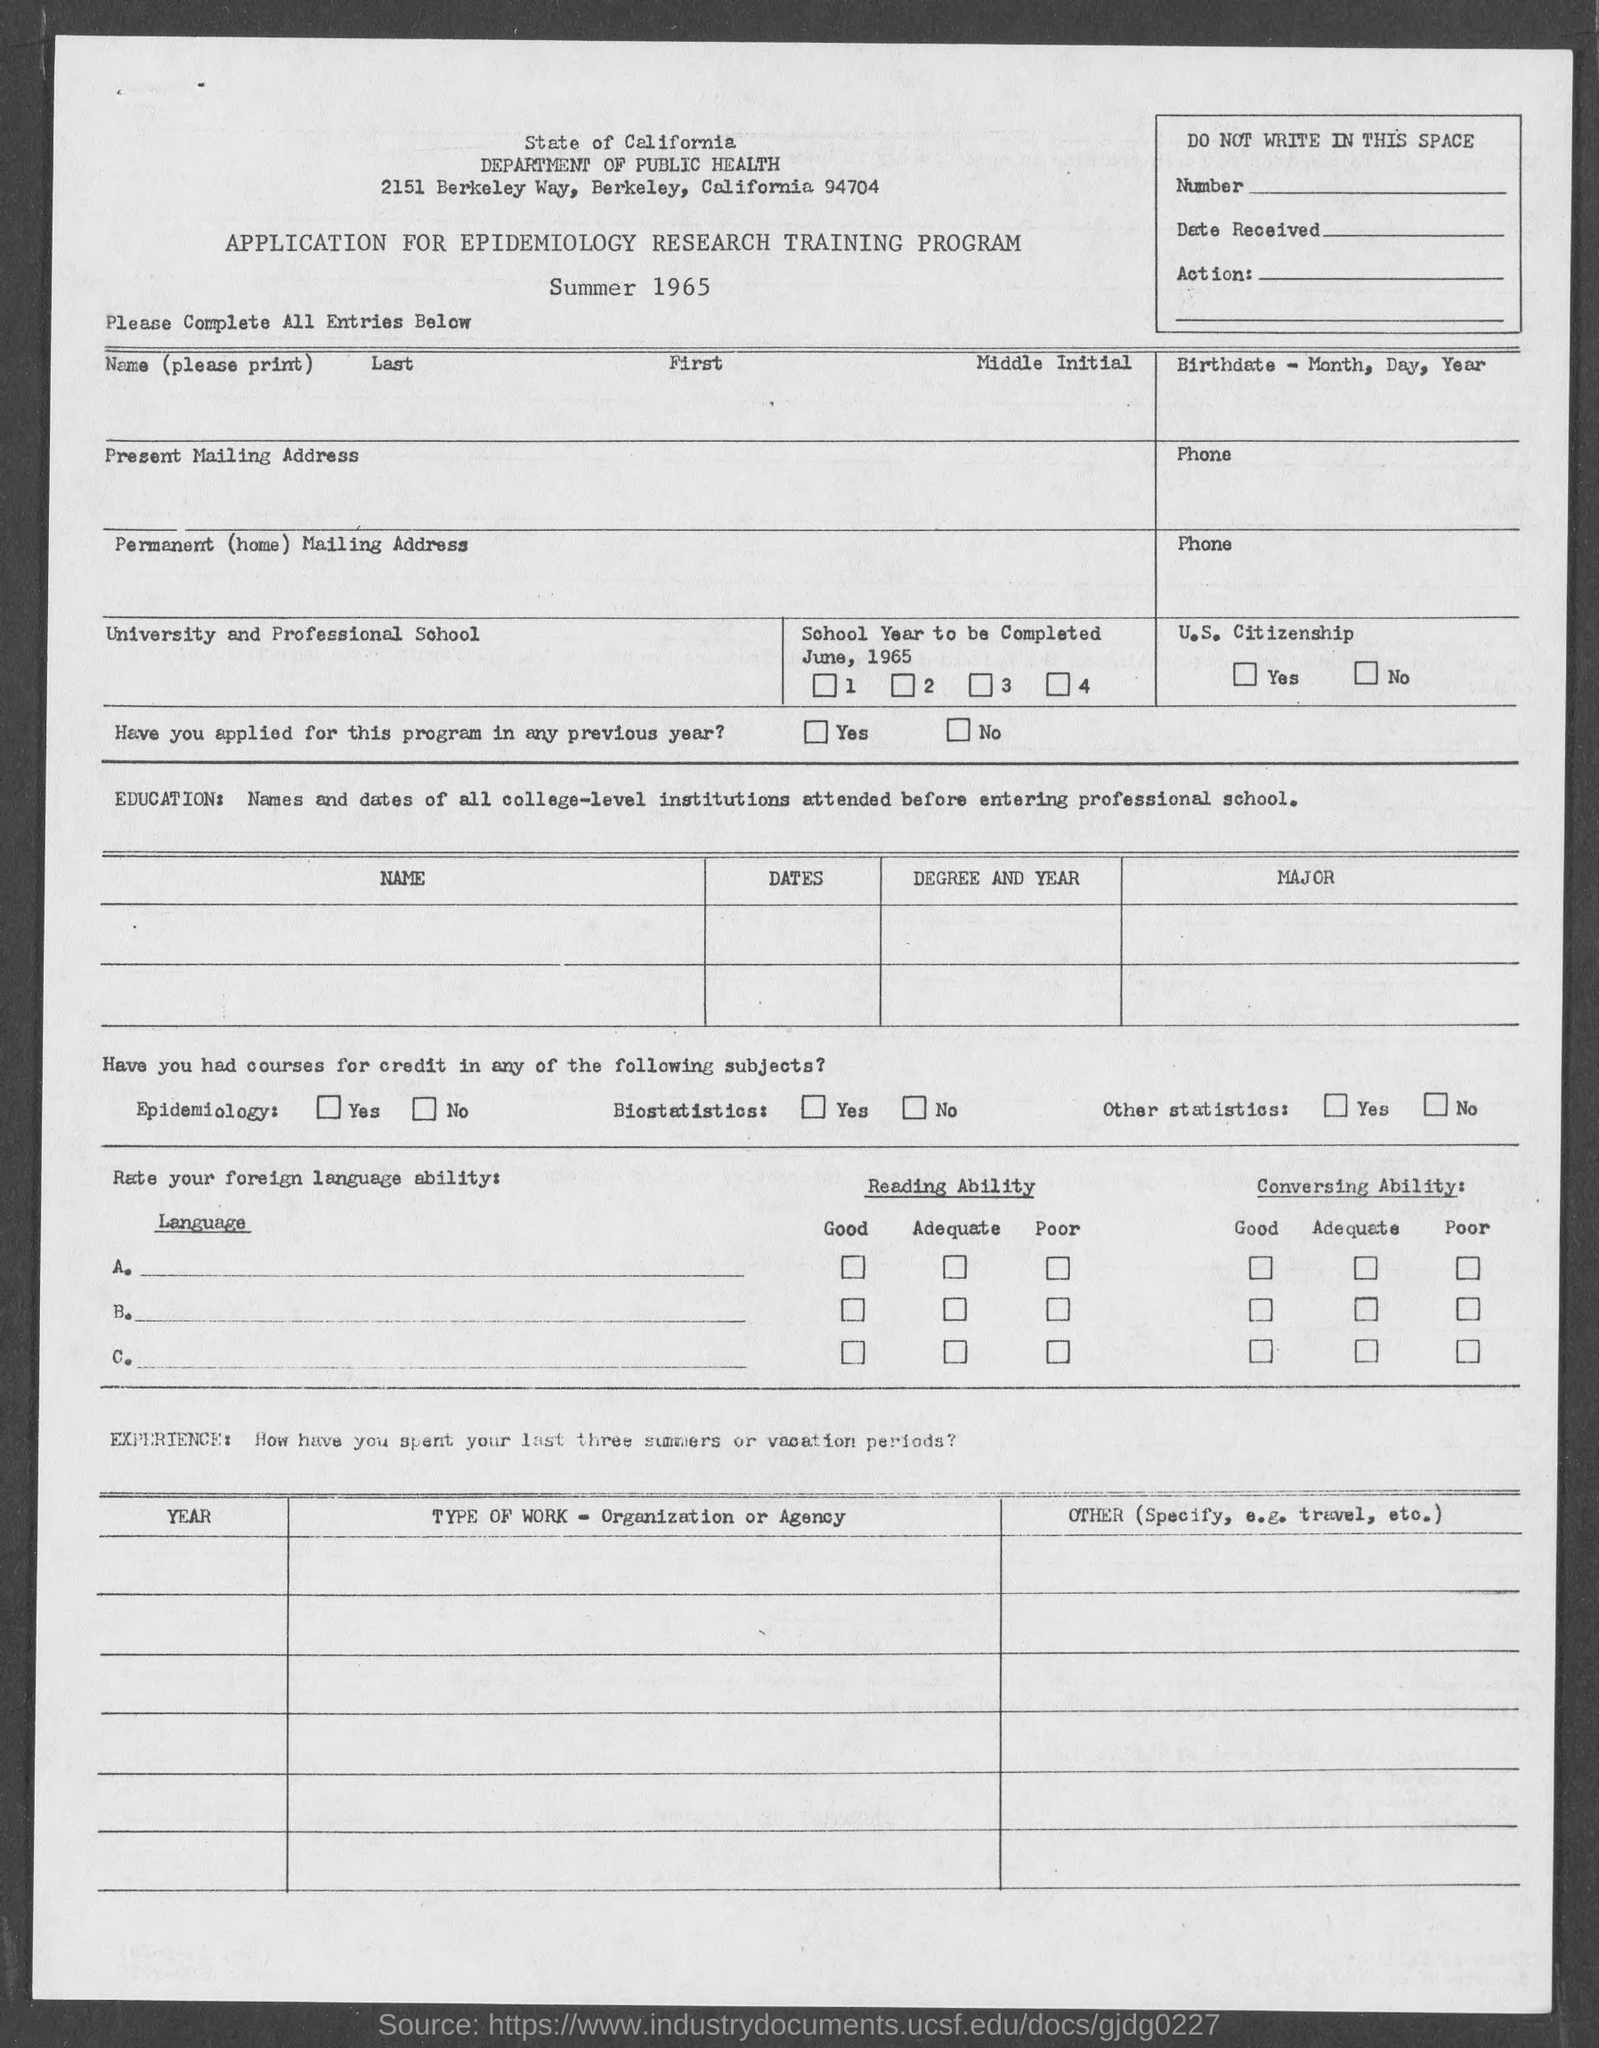In which city is department of public health at?
Give a very brief answer. Berkeley. 